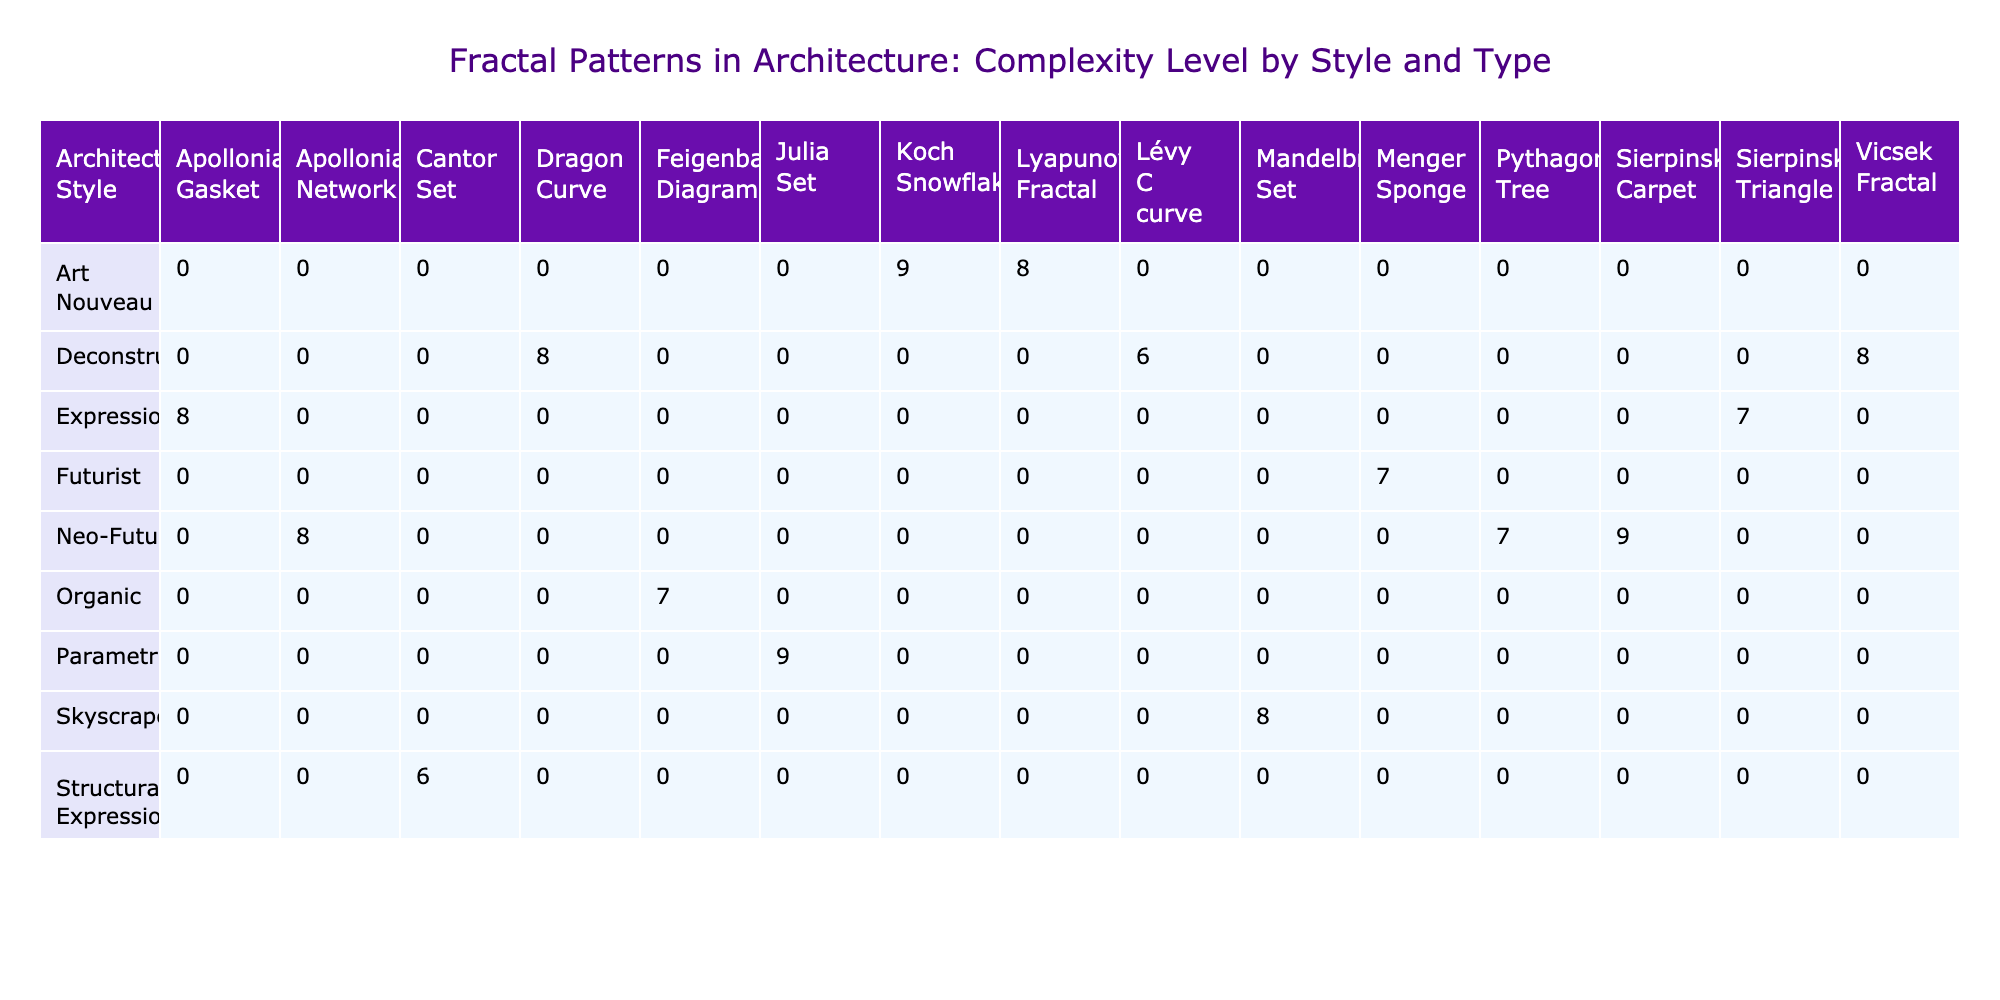What is the highest complexity level of any fractal type? Looking at the table, the highest complexity level listed is 9, which is associated with the fractals Koch Snowflake, Julia Set, and Sierpinski Carpet.
Answer: 9 Which architectural style has the most diverse fractal types? By reviewing the table, the "Contemporary" architectural style has the highest number of different fractal types listed (5 types: Sierpinski Triangle, Julia Set, Dragon Curve, Pythagoras Tree, Vicsek Fractal).
Answer: Contemporary What is the average complexity level of fractals associated with the Skyscraper style? The Skyscraper style includes only one entry, the Chrysler Building with a complexity level of 8. Therefore, the average complexity is 8, as there is no need for further calculations.
Answer: 8 Are there any fractals with a complexity level of 6 in the table? Yes, the Cantor Set and Lévy C curve are both associated with complexity level 6 in their respective architectural styles.
Answer: Yes What is the difference in average complexity level between Organic and Neo-Futurist architectural styles? The average complexity level for Organic is 7 (from Fallingwater) and for Neo-Futurist it is 8 (from The Gherkin, Burj Khalifa, and The Shard), giving a difference of 8 - 7 = 1.
Answer: 1 Which architect has buildings associated with the highest number of different fractal types and what are they? Antoni Gaudí is associated with two fractals: Koch Snowflake and Lyapunov Fractal. No other architect has buildings associated with more than two types.
Answer: Antoni Gaudí; Koch Snowflake, Lyapunov Fractal What specific material is used in the highest building listed in the table? The Burj Khalifa is the highest building at 828 meters, and it is constructed from steel.
Answer: Steel How many buildings are associated with fractals that have a complexity level of 8? There are 5 buildings with complexity level 8: Chrysler Building, Guggenheim Museum Bilbao, Sydney Opera House, The Shard, and Beijing National Stadium.
Answer: 5 Are all buildings associated with the Art Nouveau style using stone materials? Yes, both buildings under the Art Nouveau style (Sagrada Familia and Casa Batlló) use stone or ceramic tiles as materials.
Answer: Yes 